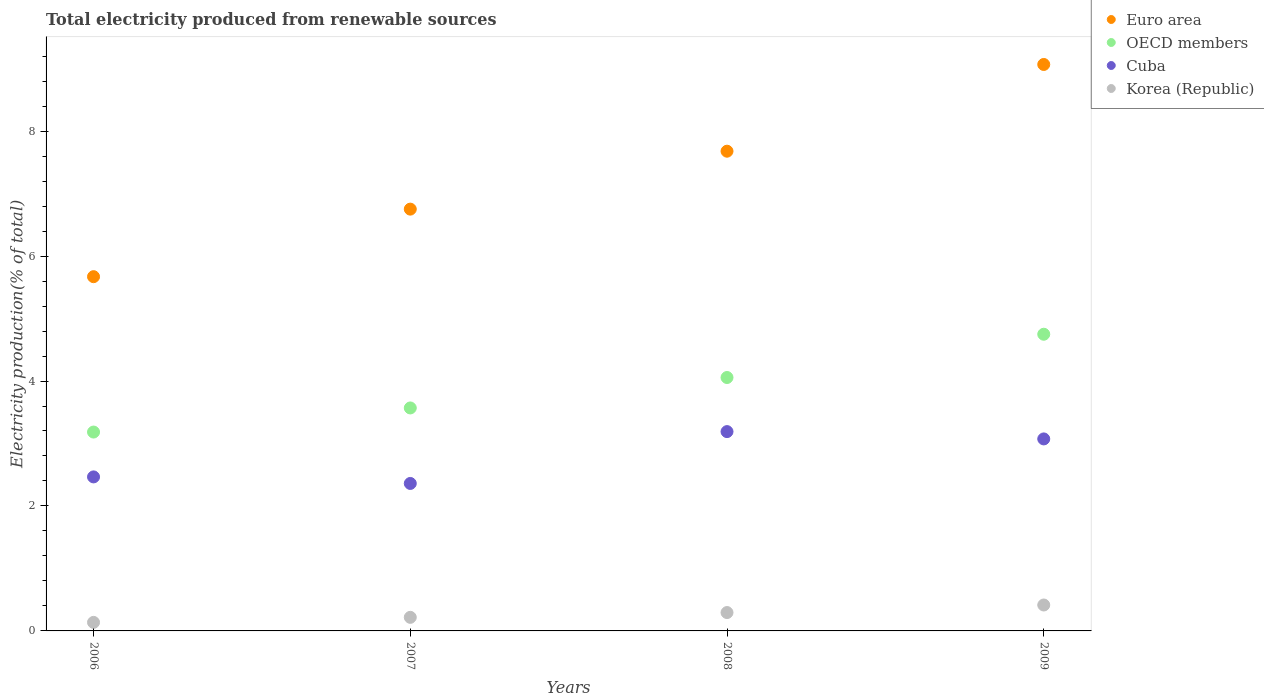Is the number of dotlines equal to the number of legend labels?
Offer a terse response. Yes. What is the total electricity produced in OECD members in 2007?
Your answer should be very brief. 3.57. Across all years, what is the maximum total electricity produced in Euro area?
Your answer should be compact. 9.07. Across all years, what is the minimum total electricity produced in OECD members?
Offer a very short reply. 3.18. In which year was the total electricity produced in OECD members maximum?
Offer a very short reply. 2009. What is the total total electricity produced in Korea (Republic) in the graph?
Offer a very short reply. 1.06. What is the difference between the total electricity produced in Cuba in 2007 and that in 2008?
Give a very brief answer. -0.83. What is the difference between the total electricity produced in Euro area in 2007 and the total electricity produced in Cuba in 2009?
Keep it short and to the point. 3.68. What is the average total electricity produced in Cuba per year?
Your answer should be compact. 2.77. In the year 2007, what is the difference between the total electricity produced in OECD members and total electricity produced in Cuba?
Offer a terse response. 1.21. What is the ratio of the total electricity produced in Cuba in 2006 to that in 2008?
Provide a succinct answer. 0.77. Is the total electricity produced in Euro area in 2006 less than that in 2008?
Provide a short and direct response. Yes. What is the difference between the highest and the second highest total electricity produced in Euro area?
Ensure brevity in your answer.  1.39. What is the difference between the highest and the lowest total electricity produced in OECD members?
Your answer should be very brief. 1.57. In how many years, is the total electricity produced in Korea (Republic) greater than the average total electricity produced in Korea (Republic) taken over all years?
Offer a terse response. 2. Is it the case that in every year, the sum of the total electricity produced in Korea (Republic) and total electricity produced in OECD members  is greater than the sum of total electricity produced in Cuba and total electricity produced in Euro area?
Keep it short and to the point. No. Is it the case that in every year, the sum of the total electricity produced in Euro area and total electricity produced in Cuba  is greater than the total electricity produced in Korea (Republic)?
Provide a short and direct response. Yes. Is the total electricity produced in Korea (Republic) strictly greater than the total electricity produced in OECD members over the years?
Your response must be concise. No. Is the total electricity produced in Korea (Republic) strictly less than the total electricity produced in Cuba over the years?
Make the answer very short. Yes. How many dotlines are there?
Keep it short and to the point. 4. What is the difference between two consecutive major ticks on the Y-axis?
Your answer should be compact. 2. Are the values on the major ticks of Y-axis written in scientific E-notation?
Your answer should be very brief. No. What is the title of the graph?
Keep it short and to the point. Total electricity produced from renewable sources. Does "Czech Republic" appear as one of the legend labels in the graph?
Ensure brevity in your answer.  No. What is the Electricity production(% of total) of Euro area in 2006?
Your answer should be very brief. 5.67. What is the Electricity production(% of total) in OECD members in 2006?
Ensure brevity in your answer.  3.18. What is the Electricity production(% of total) in Cuba in 2006?
Your response must be concise. 2.47. What is the Electricity production(% of total) of Korea (Republic) in 2006?
Your answer should be compact. 0.14. What is the Electricity production(% of total) of Euro area in 2007?
Ensure brevity in your answer.  6.75. What is the Electricity production(% of total) in OECD members in 2007?
Give a very brief answer. 3.57. What is the Electricity production(% of total) in Cuba in 2007?
Your answer should be compact. 2.36. What is the Electricity production(% of total) in Korea (Republic) in 2007?
Ensure brevity in your answer.  0.22. What is the Electricity production(% of total) in Euro area in 2008?
Provide a succinct answer. 7.68. What is the Electricity production(% of total) in OECD members in 2008?
Make the answer very short. 4.06. What is the Electricity production(% of total) in Cuba in 2008?
Your answer should be very brief. 3.19. What is the Electricity production(% of total) in Korea (Republic) in 2008?
Offer a very short reply. 0.29. What is the Electricity production(% of total) in Euro area in 2009?
Your answer should be compact. 9.07. What is the Electricity production(% of total) of OECD members in 2009?
Your response must be concise. 4.75. What is the Electricity production(% of total) in Cuba in 2009?
Provide a short and direct response. 3.07. What is the Electricity production(% of total) in Korea (Republic) in 2009?
Ensure brevity in your answer.  0.41. Across all years, what is the maximum Electricity production(% of total) in Euro area?
Your answer should be very brief. 9.07. Across all years, what is the maximum Electricity production(% of total) in OECD members?
Offer a terse response. 4.75. Across all years, what is the maximum Electricity production(% of total) in Cuba?
Make the answer very short. 3.19. Across all years, what is the maximum Electricity production(% of total) in Korea (Republic)?
Make the answer very short. 0.41. Across all years, what is the minimum Electricity production(% of total) in Euro area?
Your answer should be very brief. 5.67. Across all years, what is the minimum Electricity production(% of total) of OECD members?
Offer a terse response. 3.18. Across all years, what is the minimum Electricity production(% of total) in Cuba?
Your response must be concise. 2.36. Across all years, what is the minimum Electricity production(% of total) in Korea (Republic)?
Give a very brief answer. 0.14. What is the total Electricity production(% of total) in Euro area in the graph?
Your answer should be compact. 29.17. What is the total Electricity production(% of total) of OECD members in the graph?
Offer a terse response. 15.56. What is the total Electricity production(% of total) of Cuba in the graph?
Offer a very short reply. 11.09. What is the total Electricity production(% of total) of Korea (Republic) in the graph?
Provide a succinct answer. 1.06. What is the difference between the Electricity production(% of total) in Euro area in 2006 and that in 2007?
Your response must be concise. -1.08. What is the difference between the Electricity production(% of total) of OECD members in 2006 and that in 2007?
Provide a short and direct response. -0.39. What is the difference between the Electricity production(% of total) of Cuba in 2006 and that in 2007?
Your answer should be very brief. 0.1. What is the difference between the Electricity production(% of total) in Korea (Republic) in 2006 and that in 2007?
Your answer should be compact. -0.08. What is the difference between the Electricity production(% of total) in Euro area in 2006 and that in 2008?
Ensure brevity in your answer.  -2.01. What is the difference between the Electricity production(% of total) in OECD members in 2006 and that in 2008?
Your answer should be compact. -0.87. What is the difference between the Electricity production(% of total) of Cuba in 2006 and that in 2008?
Your response must be concise. -0.72. What is the difference between the Electricity production(% of total) of Korea (Republic) in 2006 and that in 2008?
Your answer should be compact. -0.16. What is the difference between the Electricity production(% of total) in Euro area in 2006 and that in 2009?
Offer a very short reply. -3.4. What is the difference between the Electricity production(% of total) in OECD members in 2006 and that in 2009?
Offer a very short reply. -1.57. What is the difference between the Electricity production(% of total) of Cuba in 2006 and that in 2009?
Give a very brief answer. -0.61. What is the difference between the Electricity production(% of total) of Korea (Republic) in 2006 and that in 2009?
Keep it short and to the point. -0.28. What is the difference between the Electricity production(% of total) in Euro area in 2007 and that in 2008?
Keep it short and to the point. -0.93. What is the difference between the Electricity production(% of total) of OECD members in 2007 and that in 2008?
Provide a succinct answer. -0.49. What is the difference between the Electricity production(% of total) in Cuba in 2007 and that in 2008?
Give a very brief answer. -0.83. What is the difference between the Electricity production(% of total) of Korea (Republic) in 2007 and that in 2008?
Offer a terse response. -0.08. What is the difference between the Electricity production(% of total) in Euro area in 2007 and that in 2009?
Make the answer very short. -2.32. What is the difference between the Electricity production(% of total) in OECD members in 2007 and that in 2009?
Your response must be concise. -1.18. What is the difference between the Electricity production(% of total) of Cuba in 2007 and that in 2009?
Your response must be concise. -0.71. What is the difference between the Electricity production(% of total) in Korea (Republic) in 2007 and that in 2009?
Provide a short and direct response. -0.2. What is the difference between the Electricity production(% of total) in Euro area in 2008 and that in 2009?
Provide a succinct answer. -1.39. What is the difference between the Electricity production(% of total) in OECD members in 2008 and that in 2009?
Your answer should be very brief. -0.69. What is the difference between the Electricity production(% of total) in Cuba in 2008 and that in 2009?
Ensure brevity in your answer.  0.12. What is the difference between the Electricity production(% of total) in Korea (Republic) in 2008 and that in 2009?
Your response must be concise. -0.12. What is the difference between the Electricity production(% of total) in Euro area in 2006 and the Electricity production(% of total) in OECD members in 2007?
Offer a terse response. 2.1. What is the difference between the Electricity production(% of total) in Euro area in 2006 and the Electricity production(% of total) in Cuba in 2007?
Provide a short and direct response. 3.31. What is the difference between the Electricity production(% of total) of Euro area in 2006 and the Electricity production(% of total) of Korea (Republic) in 2007?
Offer a terse response. 5.45. What is the difference between the Electricity production(% of total) of OECD members in 2006 and the Electricity production(% of total) of Cuba in 2007?
Offer a very short reply. 0.82. What is the difference between the Electricity production(% of total) in OECD members in 2006 and the Electricity production(% of total) in Korea (Republic) in 2007?
Ensure brevity in your answer.  2.97. What is the difference between the Electricity production(% of total) in Cuba in 2006 and the Electricity production(% of total) in Korea (Republic) in 2007?
Make the answer very short. 2.25. What is the difference between the Electricity production(% of total) in Euro area in 2006 and the Electricity production(% of total) in OECD members in 2008?
Provide a short and direct response. 1.61. What is the difference between the Electricity production(% of total) of Euro area in 2006 and the Electricity production(% of total) of Cuba in 2008?
Give a very brief answer. 2.48. What is the difference between the Electricity production(% of total) in Euro area in 2006 and the Electricity production(% of total) in Korea (Republic) in 2008?
Ensure brevity in your answer.  5.38. What is the difference between the Electricity production(% of total) of OECD members in 2006 and the Electricity production(% of total) of Cuba in 2008?
Provide a short and direct response. -0.01. What is the difference between the Electricity production(% of total) in OECD members in 2006 and the Electricity production(% of total) in Korea (Republic) in 2008?
Offer a terse response. 2.89. What is the difference between the Electricity production(% of total) of Cuba in 2006 and the Electricity production(% of total) of Korea (Republic) in 2008?
Provide a short and direct response. 2.17. What is the difference between the Electricity production(% of total) in Euro area in 2006 and the Electricity production(% of total) in OECD members in 2009?
Provide a succinct answer. 0.92. What is the difference between the Electricity production(% of total) in Euro area in 2006 and the Electricity production(% of total) in Cuba in 2009?
Your answer should be compact. 2.6. What is the difference between the Electricity production(% of total) of Euro area in 2006 and the Electricity production(% of total) of Korea (Republic) in 2009?
Your response must be concise. 5.26. What is the difference between the Electricity production(% of total) in OECD members in 2006 and the Electricity production(% of total) in Cuba in 2009?
Ensure brevity in your answer.  0.11. What is the difference between the Electricity production(% of total) of OECD members in 2006 and the Electricity production(% of total) of Korea (Republic) in 2009?
Make the answer very short. 2.77. What is the difference between the Electricity production(% of total) in Cuba in 2006 and the Electricity production(% of total) in Korea (Republic) in 2009?
Keep it short and to the point. 2.05. What is the difference between the Electricity production(% of total) in Euro area in 2007 and the Electricity production(% of total) in OECD members in 2008?
Offer a very short reply. 2.7. What is the difference between the Electricity production(% of total) of Euro area in 2007 and the Electricity production(% of total) of Cuba in 2008?
Keep it short and to the point. 3.56. What is the difference between the Electricity production(% of total) in Euro area in 2007 and the Electricity production(% of total) in Korea (Republic) in 2008?
Give a very brief answer. 6.46. What is the difference between the Electricity production(% of total) of OECD members in 2007 and the Electricity production(% of total) of Cuba in 2008?
Your response must be concise. 0.38. What is the difference between the Electricity production(% of total) in OECD members in 2007 and the Electricity production(% of total) in Korea (Republic) in 2008?
Your response must be concise. 3.27. What is the difference between the Electricity production(% of total) of Cuba in 2007 and the Electricity production(% of total) of Korea (Republic) in 2008?
Provide a short and direct response. 2.07. What is the difference between the Electricity production(% of total) in Euro area in 2007 and the Electricity production(% of total) in OECD members in 2009?
Your response must be concise. 2. What is the difference between the Electricity production(% of total) of Euro area in 2007 and the Electricity production(% of total) of Cuba in 2009?
Your response must be concise. 3.68. What is the difference between the Electricity production(% of total) in Euro area in 2007 and the Electricity production(% of total) in Korea (Republic) in 2009?
Your answer should be very brief. 6.34. What is the difference between the Electricity production(% of total) in OECD members in 2007 and the Electricity production(% of total) in Cuba in 2009?
Your answer should be very brief. 0.5. What is the difference between the Electricity production(% of total) in OECD members in 2007 and the Electricity production(% of total) in Korea (Republic) in 2009?
Provide a short and direct response. 3.15. What is the difference between the Electricity production(% of total) in Cuba in 2007 and the Electricity production(% of total) in Korea (Republic) in 2009?
Make the answer very short. 1.95. What is the difference between the Electricity production(% of total) in Euro area in 2008 and the Electricity production(% of total) in OECD members in 2009?
Offer a very short reply. 2.93. What is the difference between the Electricity production(% of total) of Euro area in 2008 and the Electricity production(% of total) of Cuba in 2009?
Make the answer very short. 4.61. What is the difference between the Electricity production(% of total) of Euro area in 2008 and the Electricity production(% of total) of Korea (Republic) in 2009?
Your answer should be very brief. 7.26. What is the difference between the Electricity production(% of total) in OECD members in 2008 and the Electricity production(% of total) in Korea (Republic) in 2009?
Ensure brevity in your answer.  3.64. What is the difference between the Electricity production(% of total) of Cuba in 2008 and the Electricity production(% of total) of Korea (Republic) in 2009?
Make the answer very short. 2.78. What is the average Electricity production(% of total) of Euro area per year?
Give a very brief answer. 7.29. What is the average Electricity production(% of total) of OECD members per year?
Provide a succinct answer. 3.89. What is the average Electricity production(% of total) of Cuba per year?
Your answer should be compact. 2.77. What is the average Electricity production(% of total) of Korea (Republic) per year?
Make the answer very short. 0.27. In the year 2006, what is the difference between the Electricity production(% of total) of Euro area and Electricity production(% of total) of OECD members?
Your response must be concise. 2.49. In the year 2006, what is the difference between the Electricity production(% of total) of Euro area and Electricity production(% of total) of Cuba?
Your answer should be very brief. 3.2. In the year 2006, what is the difference between the Electricity production(% of total) of Euro area and Electricity production(% of total) of Korea (Republic)?
Provide a succinct answer. 5.53. In the year 2006, what is the difference between the Electricity production(% of total) of OECD members and Electricity production(% of total) of Cuba?
Give a very brief answer. 0.72. In the year 2006, what is the difference between the Electricity production(% of total) of OECD members and Electricity production(% of total) of Korea (Republic)?
Offer a very short reply. 3.05. In the year 2006, what is the difference between the Electricity production(% of total) in Cuba and Electricity production(% of total) in Korea (Republic)?
Your answer should be compact. 2.33. In the year 2007, what is the difference between the Electricity production(% of total) of Euro area and Electricity production(% of total) of OECD members?
Keep it short and to the point. 3.18. In the year 2007, what is the difference between the Electricity production(% of total) in Euro area and Electricity production(% of total) in Cuba?
Ensure brevity in your answer.  4.39. In the year 2007, what is the difference between the Electricity production(% of total) in Euro area and Electricity production(% of total) in Korea (Republic)?
Ensure brevity in your answer.  6.53. In the year 2007, what is the difference between the Electricity production(% of total) of OECD members and Electricity production(% of total) of Cuba?
Your response must be concise. 1.21. In the year 2007, what is the difference between the Electricity production(% of total) in OECD members and Electricity production(% of total) in Korea (Republic)?
Your response must be concise. 3.35. In the year 2007, what is the difference between the Electricity production(% of total) in Cuba and Electricity production(% of total) in Korea (Republic)?
Make the answer very short. 2.14. In the year 2008, what is the difference between the Electricity production(% of total) of Euro area and Electricity production(% of total) of OECD members?
Your answer should be very brief. 3.62. In the year 2008, what is the difference between the Electricity production(% of total) of Euro area and Electricity production(% of total) of Cuba?
Provide a succinct answer. 4.49. In the year 2008, what is the difference between the Electricity production(% of total) of Euro area and Electricity production(% of total) of Korea (Republic)?
Provide a succinct answer. 7.38. In the year 2008, what is the difference between the Electricity production(% of total) of OECD members and Electricity production(% of total) of Cuba?
Offer a terse response. 0.87. In the year 2008, what is the difference between the Electricity production(% of total) of OECD members and Electricity production(% of total) of Korea (Republic)?
Give a very brief answer. 3.76. In the year 2008, what is the difference between the Electricity production(% of total) in Cuba and Electricity production(% of total) in Korea (Republic)?
Your answer should be compact. 2.9. In the year 2009, what is the difference between the Electricity production(% of total) of Euro area and Electricity production(% of total) of OECD members?
Offer a very short reply. 4.32. In the year 2009, what is the difference between the Electricity production(% of total) of Euro area and Electricity production(% of total) of Cuba?
Give a very brief answer. 5.99. In the year 2009, what is the difference between the Electricity production(% of total) of Euro area and Electricity production(% of total) of Korea (Republic)?
Offer a terse response. 8.65. In the year 2009, what is the difference between the Electricity production(% of total) of OECD members and Electricity production(% of total) of Cuba?
Offer a terse response. 1.68. In the year 2009, what is the difference between the Electricity production(% of total) in OECD members and Electricity production(% of total) in Korea (Republic)?
Your answer should be very brief. 4.33. In the year 2009, what is the difference between the Electricity production(% of total) in Cuba and Electricity production(% of total) in Korea (Republic)?
Provide a succinct answer. 2.66. What is the ratio of the Electricity production(% of total) of Euro area in 2006 to that in 2007?
Give a very brief answer. 0.84. What is the ratio of the Electricity production(% of total) of OECD members in 2006 to that in 2007?
Ensure brevity in your answer.  0.89. What is the ratio of the Electricity production(% of total) of Cuba in 2006 to that in 2007?
Make the answer very short. 1.04. What is the ratio of the Electricity production(% of total) of Korea (Republic) in 2006 to that in 2007?
Offer a terse response. 0.63. What is the ratio of the Electricity production(% of total) of Euro area in 2006 to that in 2008?
Offer a very short reply. 0.74. What is the ratio of the Electricity production(% of total) of OECD members in 2006 to that in 2008?
Your answer should be compact. 0.78. What is the ratio of the Electricity production(% of total) of Cuba in 2006 to that in 2008?
Offer a terse response. 0.77. What is the ratio of the Electricity production(% of total) in Korea (Republic) in 2006 to that in 2008?
Offer a terse response. 0.47. What is the ratio of the Electricity production(% of total) of Euro area in 2006 to that in 2009?
Your response must be concise. 0.63. What is the ratio of the Electricity production(% of total) in OECD members in 2006 to that in 2009?
Give a very brief answer. 0.67. What is the ratio of the Electricity production(% of total) of Cuba in 2006 to that in 2009?
Offer a very short reply. 0.8. What is the ratio of the Electricity production(% of total) in Korea (Republic) in 2006 to that in 2009?
Ensure brevity in your answer.  0.33. What is the ratio of the Electricity production(% of total) of Euro area in 2007 to that in 2008?
Your answer should be compact. 0.88. What is the ratio of the Electricity production(% of total) in OECD members in 2007 to that in 2008?
Ensure brevity in your answer.  0.88. What is the ratio of the Electricity production(% of total) in Cuba in 2007 to that in 2008?
Your answer should be compact. 0.74. What is the ratio of the Electricity production(% of total) in Korea (Republic) in 2007 to that in 2008?
Your response must be concise. 0.74. What is the ratio of the Electricity production(% of total) of Euro area in 2007 to that in 2009?
Your answer should be compact. 0.74. What is the ratio of the Electricity production(% of total) of OECD members in 2007 to that in 2009?
Ensure brevity in your answer.  0.75. What is the ratio of the Electricity production(% of total) of Cuba in 2007 to that in 2009?
Offer a terse response. 0.77. What is the ratio of the Electricity production(% of total) of Korea (Republic) in 2007 to that in 2009?
Keep it short and to the point. 0.52. What is the ratio of the Electricity production(% of total) of Euro area in 2008 to that in 2009?
Your answer should be very brief. 0.85. What is the ratio of the Electricity production(% of total) of OECD members in 2008 to that in 2009?
Your answer should be very brief. 0.85. What is the ratio of the Electricity production(% of total) in Cuba in 2008 to that in 2009?
Ensure brevity in your answer.  1.04. What is the ratio of the Electricity production(% of total) in Korea (Republic) in 2008 to that in 2009?
Give a very brief answer. 0.71. What is the difference between the highest and the second highest Electricity production(% of total) in Euro area?
Provide a succinct answer. 1.39. What is the difference between the highest and the second highest Electricity production(% of total) in OECD members?
Make the answer very short. 0.69. What is the difference between the highest and the second highest Electricity production(% of total) of Cuba?
Offer a terse response. 0.12. What is the difference between the highest and the second highest Electricity production(% of total) in Korea (Republic)?
Ensure brevity in your answer.  0.12. What is the difference between the highest and the lowest Electricity production(% of total) in Euro area?
Your response must be concise. 3.4. What is the difference between the highest and the lowest Electricity production(% of total) in OECD members?
Keep it short and to the point. 1.57. What is the difference between the highest and the lowest Electricity production(% of total) of Cuba?
Make the answer very short. 0.83. What is the difference between the highest and the lowest Electricity production(% of total) in Korea (Republic)?
Your response must be concise. 0.28. 